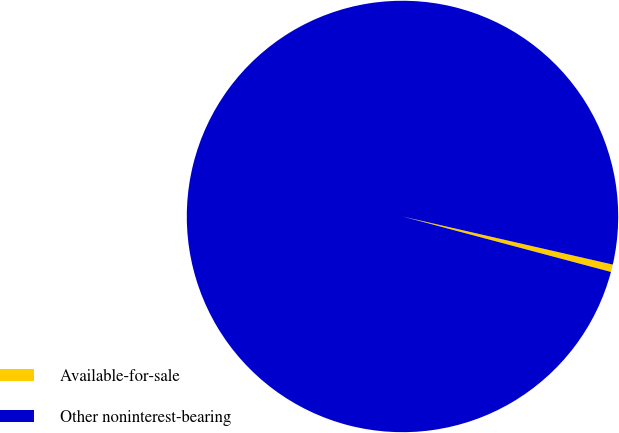<chart> <loc_0><loc_0><loc_500><loc_500><pie_chart><fcel>Available-for-sale<fcel>Other noninterest-bearing<nl><fcel>0.56%<fcel>99.44%<nl></chart> 